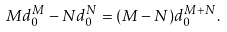Convert formula to latex. <formula><loc_0><loc_0><loc_500><loc_500>M d ^ { M } _ { 0 } - N d ^ { N } _ { 0 } = ( M - N ) d ^ { M + N } _ { 0 } .</formula> 